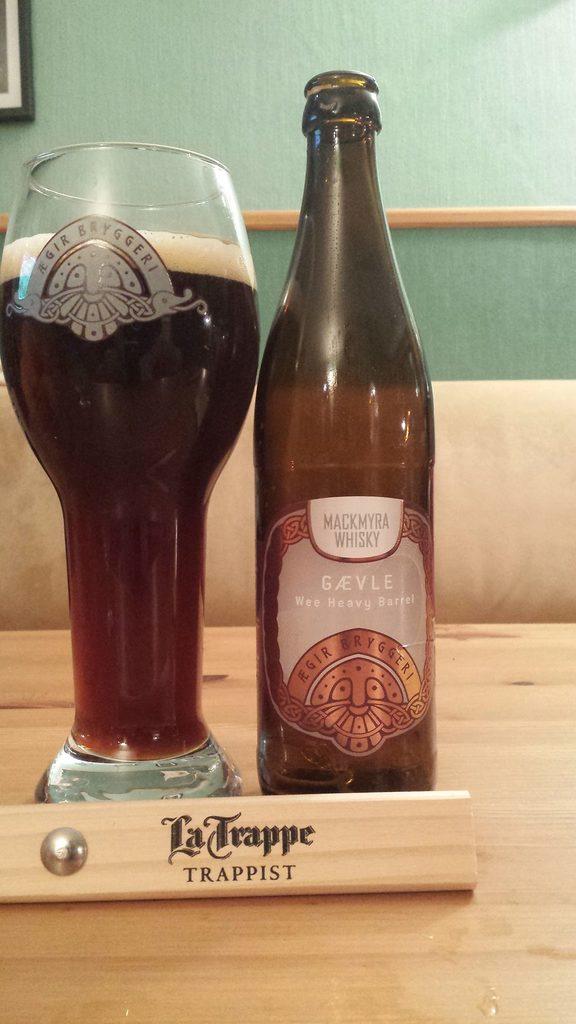What kind of beverage is in the glass?
Offer a terse response. Whiskey. What is written on the wood in front of the bottle and glass?
Provide a succinct answer. La trappe trappist. 